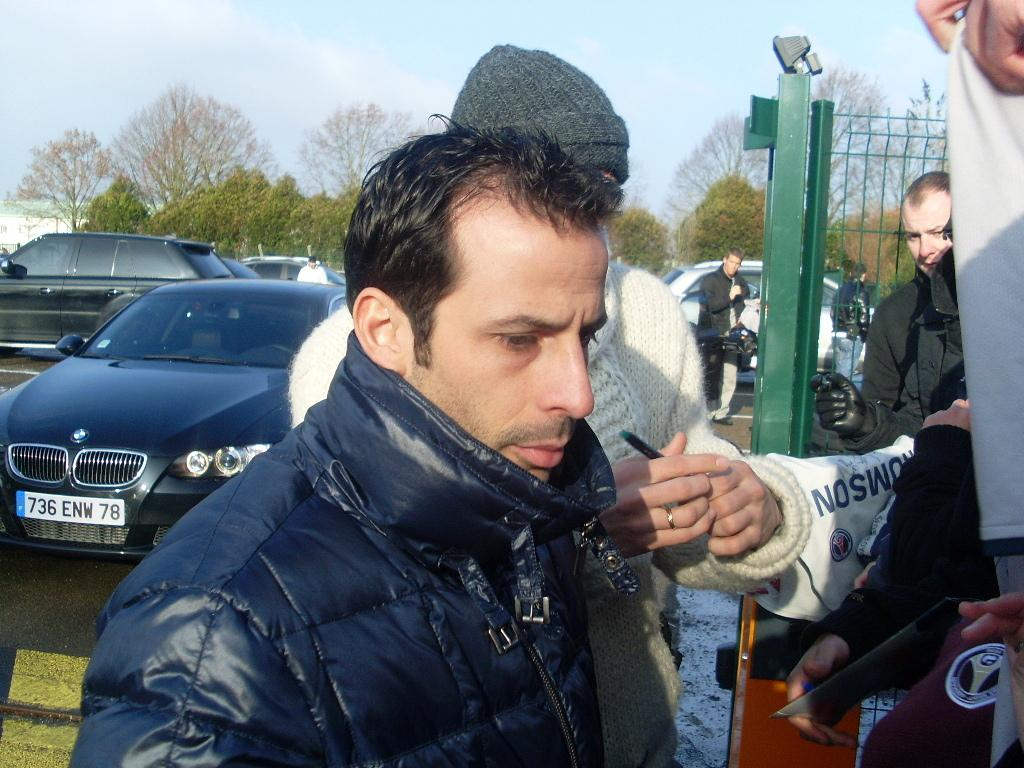How many people are in the image? There is a group of people in the image, but the exact number is not specified. What is the fence used for in the image? The purpose of the fence in the image is not clear, but it could be used for separating areas or providing a boundary. What types of vehicles are in the image? The types of vehicles in the image are not specified. What kind of vegetation is present in the image? There are trees in the image. What can be seen in the background of the image? The sky is visible in the background of the image. What type of grass is being used for the plot in the image? There is no grass or plot mentioned in the image; it features a group of people, a fence, vehicles, trees, and a visible sky. 